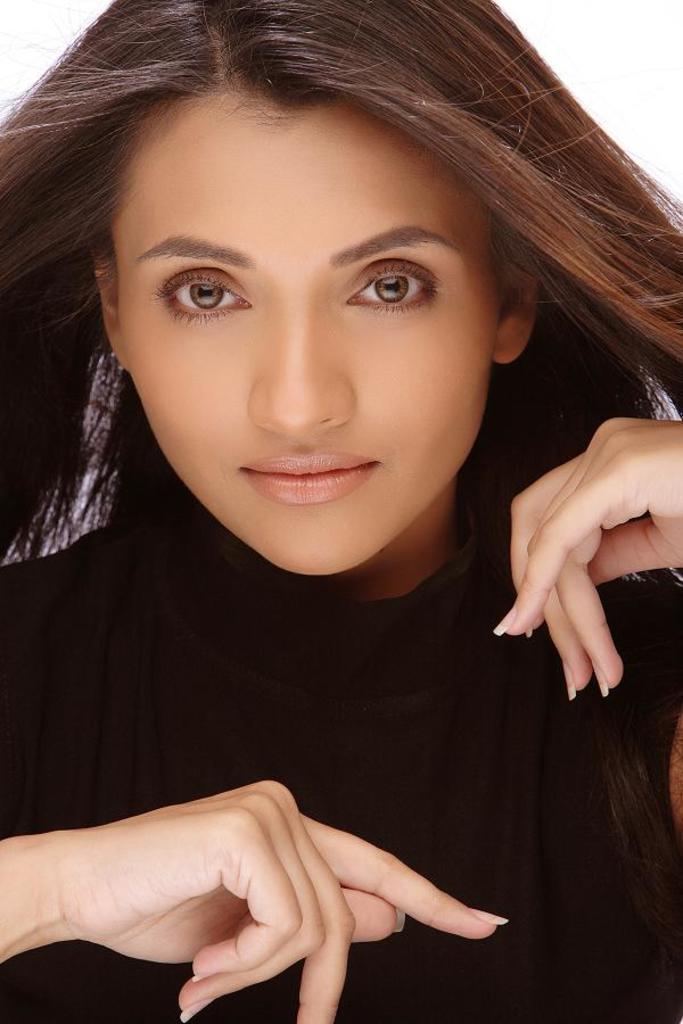Please provide a concise description of this image. In this image we can see a lady wearing black dress. 